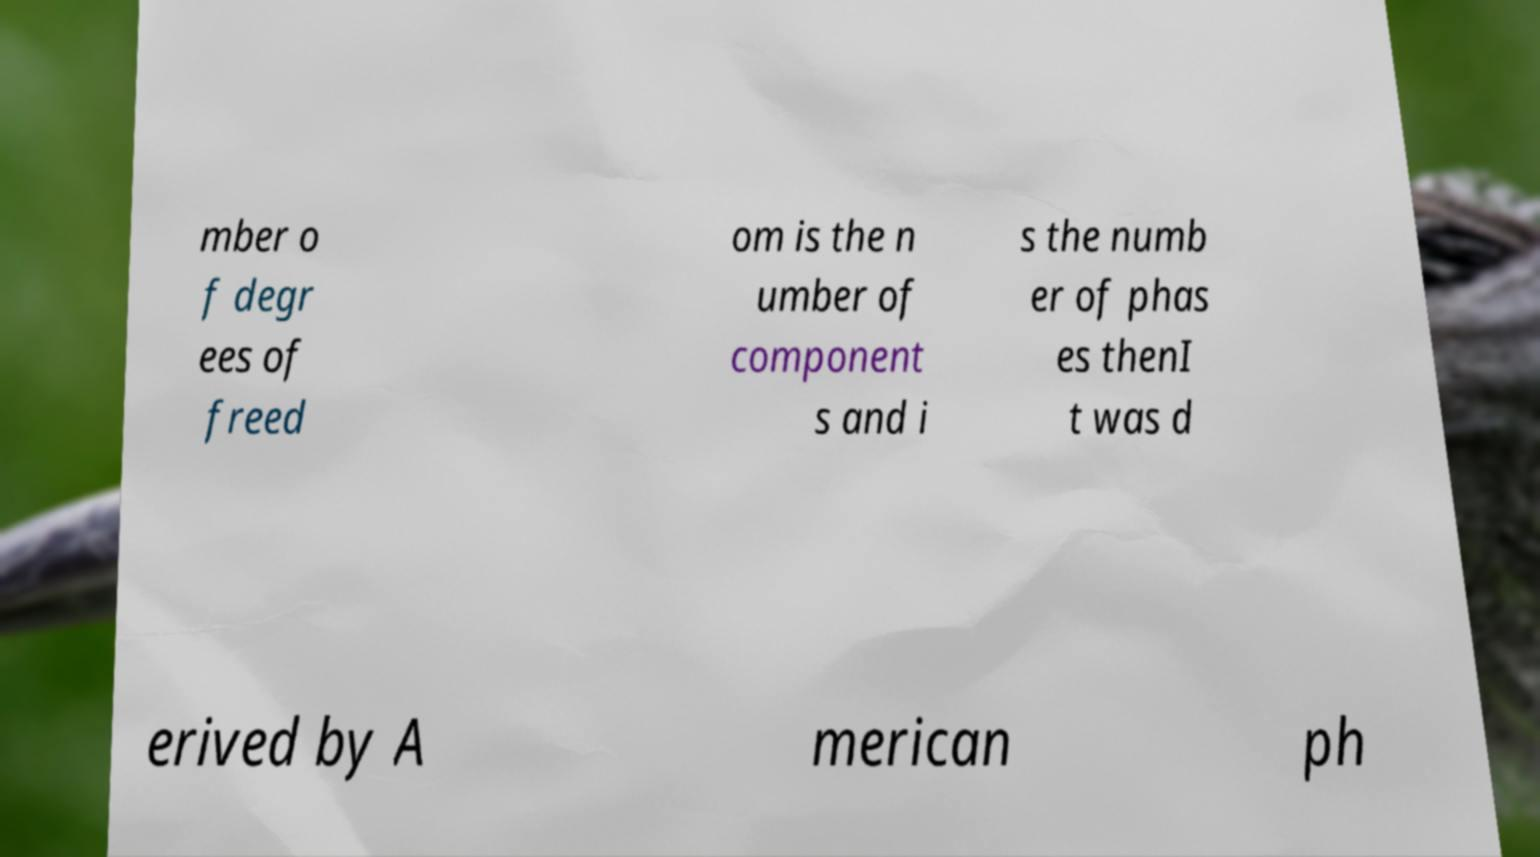Can you accurately transcribe the text from the provided image for me? mber o f degr ees of freed om is the n umber of component s and i s the numb er of phas es thenI t was d erived by A merican ph 